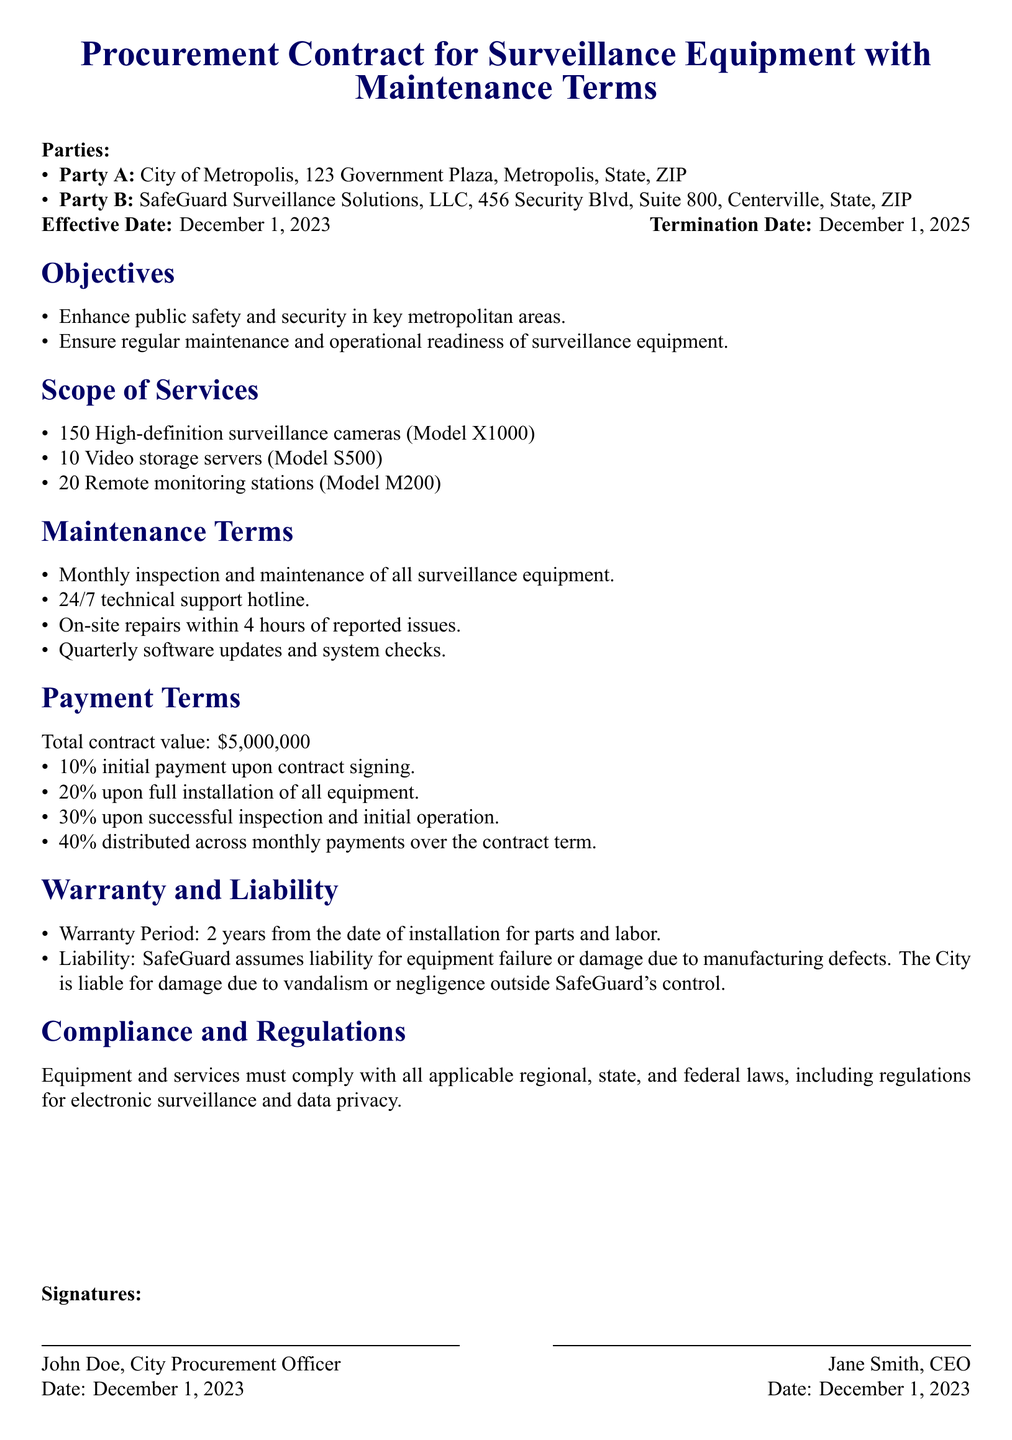What is the effective date of the contract? The effective date is specified in the document as the date when the contract becomes active.
Answer: December 1, 2023 Who is Party B? The document lists Party B as the entity providing the services under the contract.
Answer: SafeGuard Surveillance Solutions, LLC How many high-definition surveillance cameras are included in the contract? The number of cameras is part of the scope of services outlined in the document.
Answer: 150 What percentage of the total contract value is the initial payment? The percentage for the initial payment is specifically mentioned in the payment terms section.
Answer: 10% What is the warranty period for parts and labor? The document states the warranty duration for the equipment and services provided under the contract.
Answer: 2 years What is the total contract value? The total value is explicitly indicated in the payment terms section of the document.
Answer: $5,000,000 What type of support is provided 24/7? The type of support available at all times is specified in the maintenance terms section.
Answer: Technical support hotline Who is liable for damage due to vandalism? The liability for vandalism is detailed in the warranty and liability section of the contract.
Answer: The City 